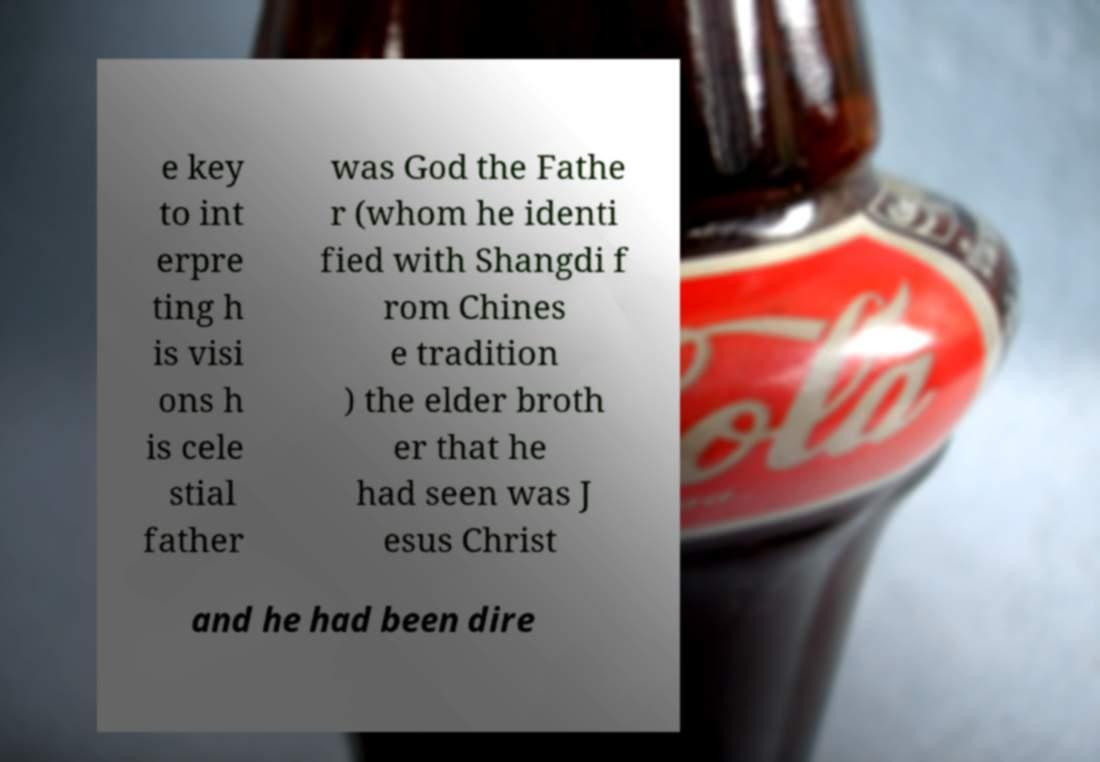Could you assist in decoding the text presented in this image and type it out clearly? e key to int erpre ting h is visi ons h is cele stial father was God the Fathe r (whom he identi fied with Shangdi f rom Chines e tradition ) the elder broth er that he had seen was J esus Christ and he had been dire 